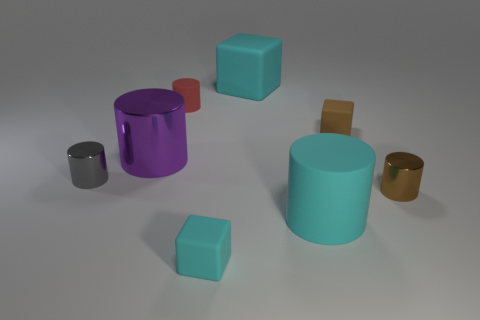Add 1 large cyan things. How many objects exist? 9 Subtract all big cyan matte blocks. How many blocks are left? 2 Subtract 1 cubes. How many cubes are left? 2 Subtract all red cylinders. How many cylinders are left? 4 Subtract all cubes. How many objects are left? 5 Subtract all brown cylinders. Subtract all brown spheres. How many cylinders are left? 4 Subtract all purple spheres. How many cyan cylinders are left? 1 Subtract all tiny metal objects. Subtract all big cyan blocks. How many objects are left? 5 Add 5 tiny shiny things. How many tiny shiny things are left? 7 Add 1 big purple cylinders. How many big purple cylinders exist? 2 